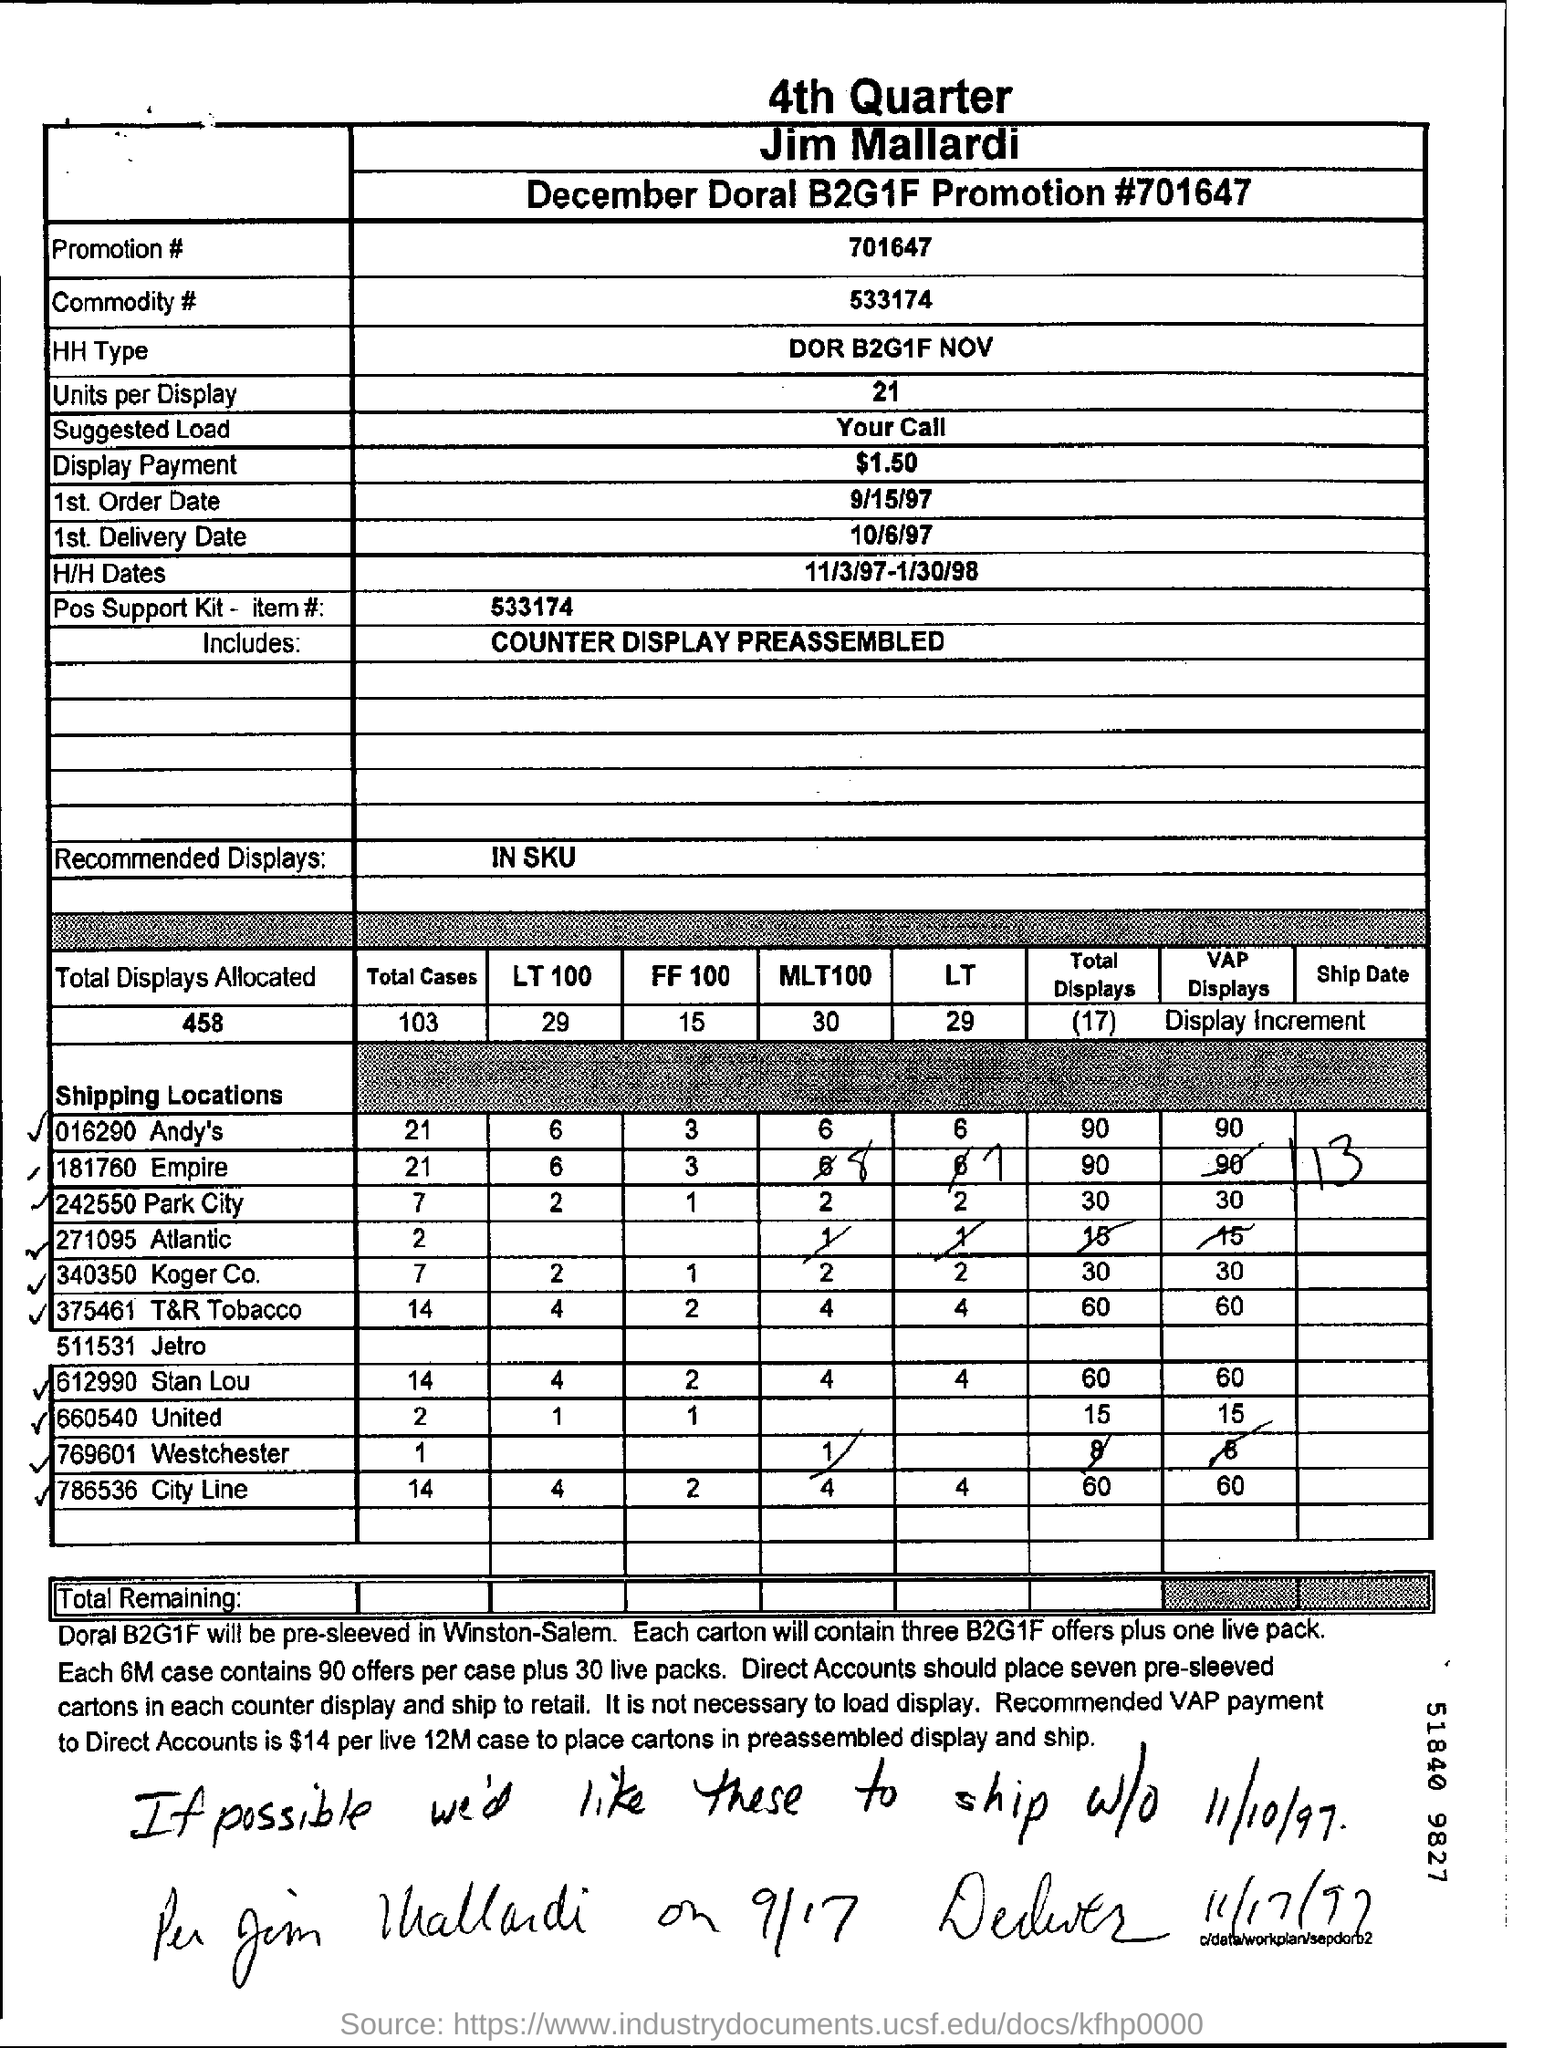What is the Promotion #?
Give a very brief answer. 701647. What is the Commodity #?
Your response must be concise. 533174. What is the Pos Support Kit - item #?
Keep it short and to the point. 533174. How many Units per Display?
Ensure brevity in your answer.  21. What is the 1st. Order Date?
Your answer should be compact. 9/15/97. 